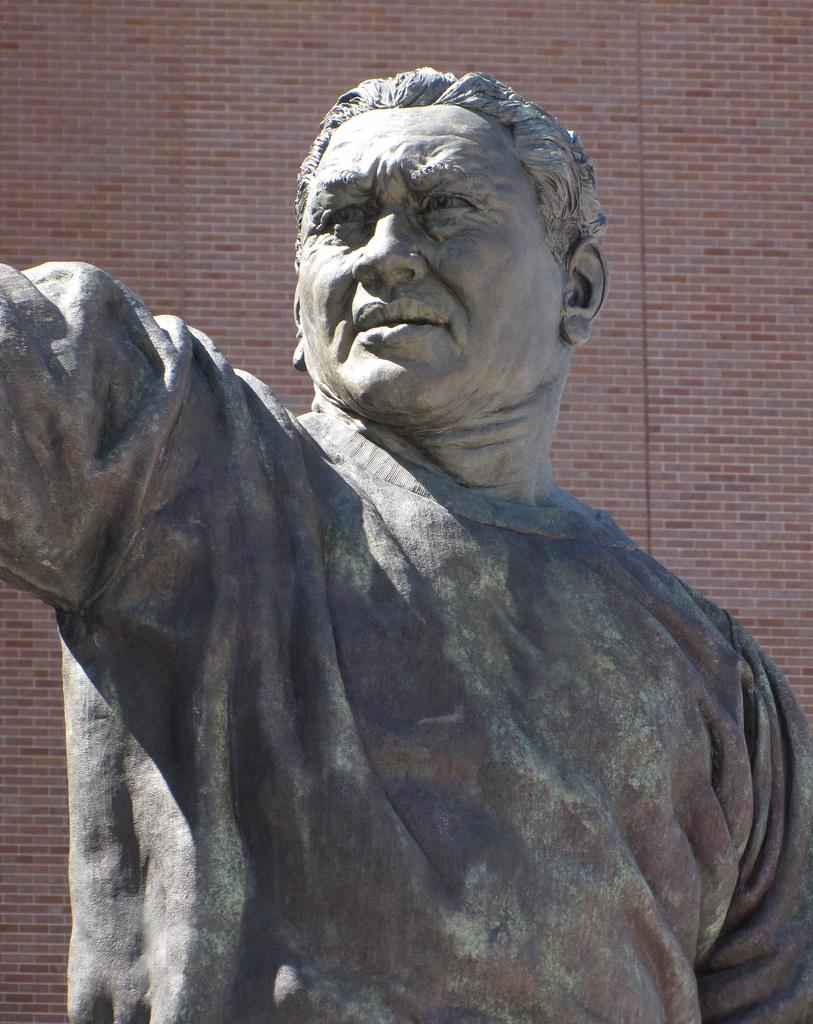What is the main subject in the image? There is a statue in the image. What can be seen in the background of the image? There is a brick wall in the background of the image. What type of eggnog is being served in the image? There is no eggnog present in the image; it features a statue and a brick wall. What type of prison can be seen in the image? There is no prison present in the image; it features a statue and a brick wall. 